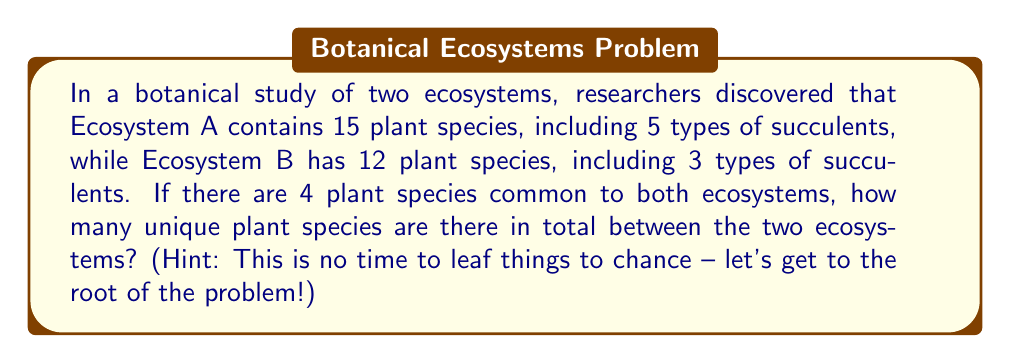Can you solve this math problem? Let's approach this step-by-step using set theory:

1) Let $A$ represent the set of plant species in Ecosystem A, and $B$ represent the set of plant species in Ecosystem B.

2) We're given:
   $|A| = 15$ (cardinality of set A)
   $|B| = 12$ (cardinality of set B)
   $|A \cap B| = 4$ (cardinality of the intersection of A and B)

3) We need to find the total number of unique plant species, which is represented by the union of sets A and B: $|A \cup B|$

4) We can use the formula for the cardinality of the union of two sets:

   $|A \cup B| = |A| + |B| - |A \cap B|$

5) Substituting the values:

   $|A \cup B| = 15 + 12 - 4$

6) Calculating:

   $|A \cup B| = 27 - 4 = 23$

Therefore, there are 23 unique plant species in total between the two ecosystems.

Note: The information about succulents, while interesting, is not necessary for solving this particular problem. It's just there to add some flavor to our botanical adventure!
Answer: 23 unique plant species 